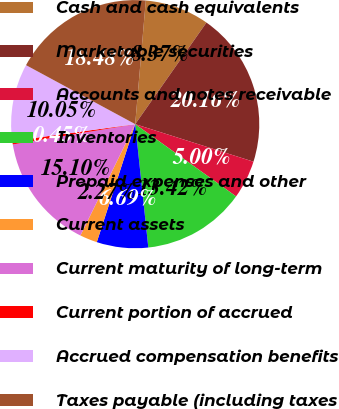Convert chart to OTSL. <chart><loc_0><loc_0><loc_500><loc_500><pie_chart><fcel>Cash and cash equivalents<fcel>Marketable securities<fcel>Accounts and notes receivable<fcel>Inventories<fcel>Prepaid expenses and other<fcel>Current assets<fcel>Current maturity of long-term<fcel>Current portion of accrued<fcel>Accrued compensation benefits<fcel>Taxes payable (including taxes<nl><fcel>8.37%<fcel>20.15%<fcel>5.0%<fcel>13.42%<fcel>6.69%<fcel>2.27%<fcel>15.1%<fcel>0.45%<fcel>10.05%<fcel>18.47%<nl></chart> 